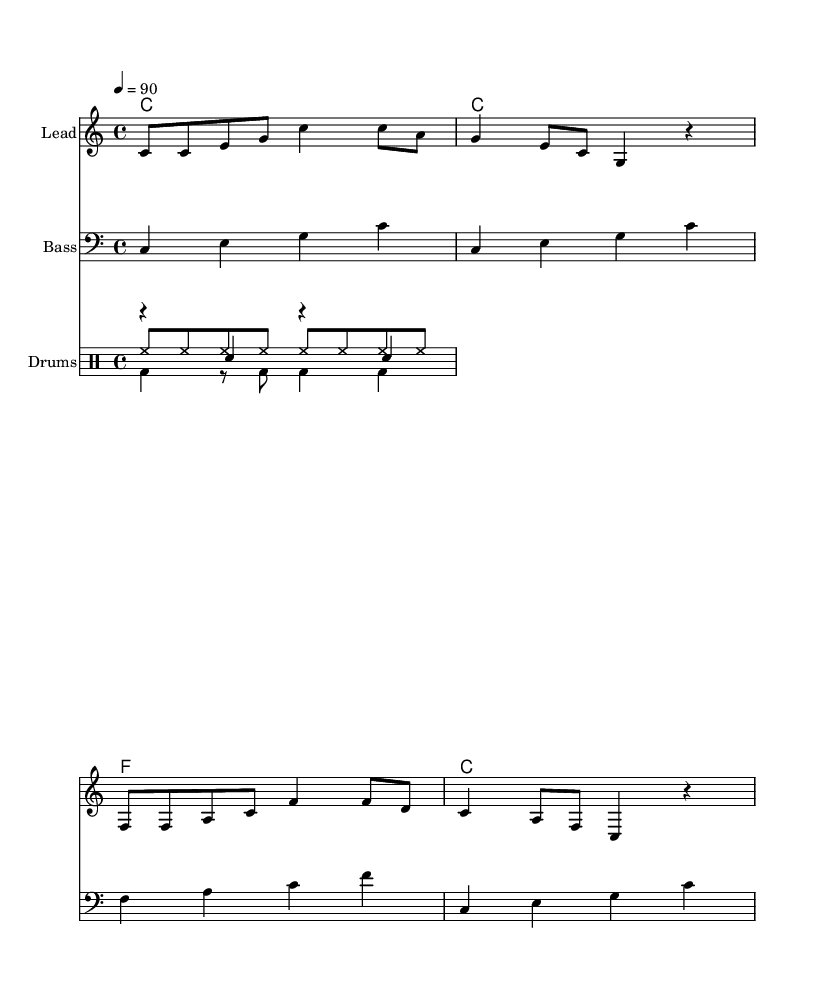What is the key signature of this music? The key signature is indicated at the beginning of the score and is C major, which has no sharps or flats.
Answer: C major What is the time signature of this music? The time signature is presented after the key signature, showing the number of beats in a measure. It is 4/4, meaning there are four beats per measure.
Answer: 4/4 What is the tempo marking? The tempo marking shows the speed of the music, indicated by "4 = 90." This means that there are 90 beats per minute.
Answer: 90 How many measures are in the melody? To determine the number of measures, we count the distinct sections separated by bar lines in the melody. There are four measures in total.
Answer: 4 What is the first line of lyrics? The first line of lyrics is found directly under the melody, starting with "Brush your teeth." This gives information about the topic of the song.
Answer: Brush your teeth, it's time to clean What type of music is this? Considering the lyrics focus on everyday tasks like cleaning teeth and the rhythmic style used, this music can be categorized as Hip Hop.
Answer: Hip Hop What rhythmic elements are used in the drum section? The drum section includes three components: hi-hat, kick, and snare. Each has its own rhythmic pattern, contributing to the overall beat and style of the hip hop track.
Answer: Hi-hat, kick, snare 